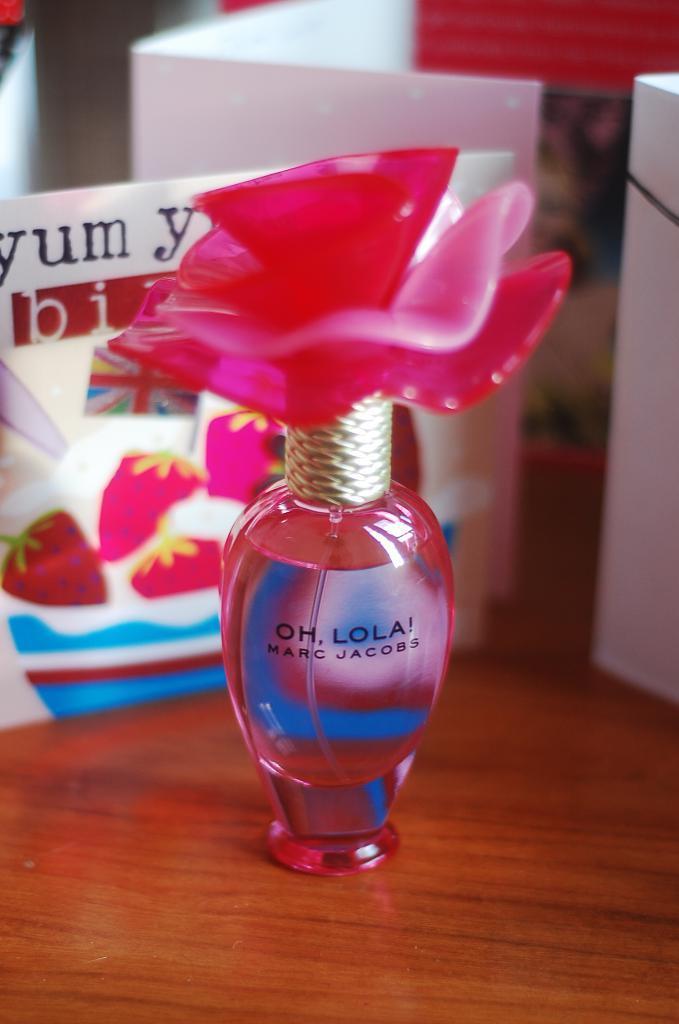<image>
Provide a brief description of the given image. A bottle of Marc Jacobs perfume is called Oh, Lola. 